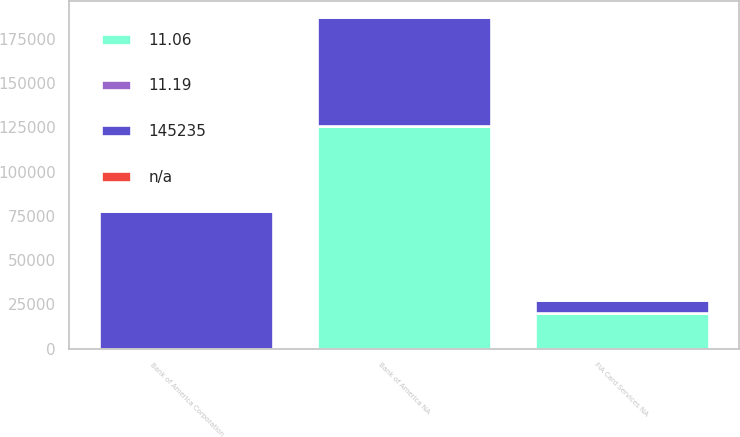Convert chart. <chart><loc_0><loc_0><loc_500><loc_500><stacked_bar_chart><ecel><fcel>Bank of America Corporation<fcel>Bank of America NA<fcel>FIA Card Services NA<nl><fcel>11.19<fcel>12.44<fcel>12.34<fcel>16.83<nl><fcel>11.06<fcel>17.34<fcel>125886<fcel>20135<nl><fcel>145235<fcel>77852<fcel>61208<fcel>7177<nl><fcel>nan<fcel>12.89<fcel>12.44<fcel>17.34<nl></chart> 